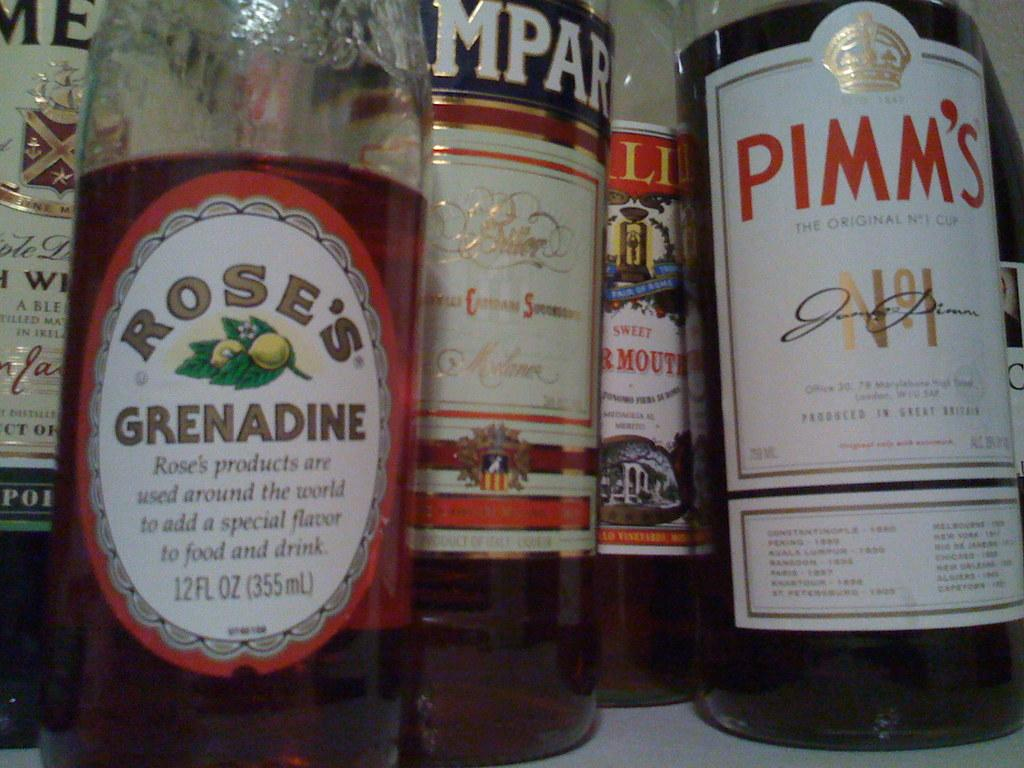<image>
Give a short and clear explanation of the subsequent image. A Rose's Grenadine liquor bottle is next to other liquor bottles. 